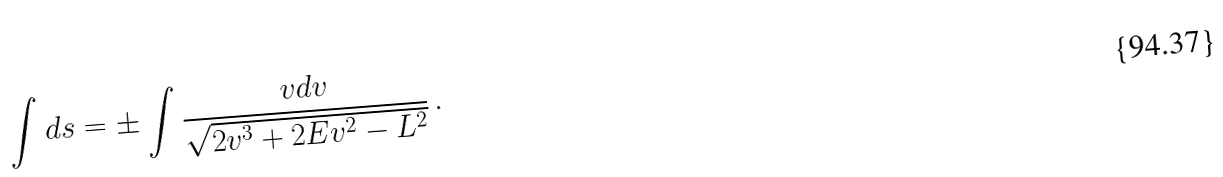Convert formula to latex. <formula><loc_0><loc_0><loc_500><loc_500>\int d s = \pm \int \frac { v d v } { \sqrt { 2 v ^ { 3 } + 2 E v ^ { 2 } - L ^ { 2 } } } \, .</formula> 